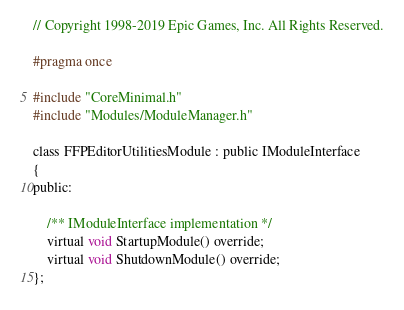Convert code to text. <code><loc_0><loc_0><loc_500><loc_500><_C_>// Copyright 1998-2019 Epic Games, Inc. All Rights Reserved.

#pragma once

#include "CoreMinimal.h"
#include "Modules/ModuleManager.h"

class FFPEditorUtilitiesModule : public IModuleInterface
{
public:

	/** IModuleInterface implementation */
	virtual void StartupModule() override;
	virtual void ShutdownModule() override;
};
</code> 